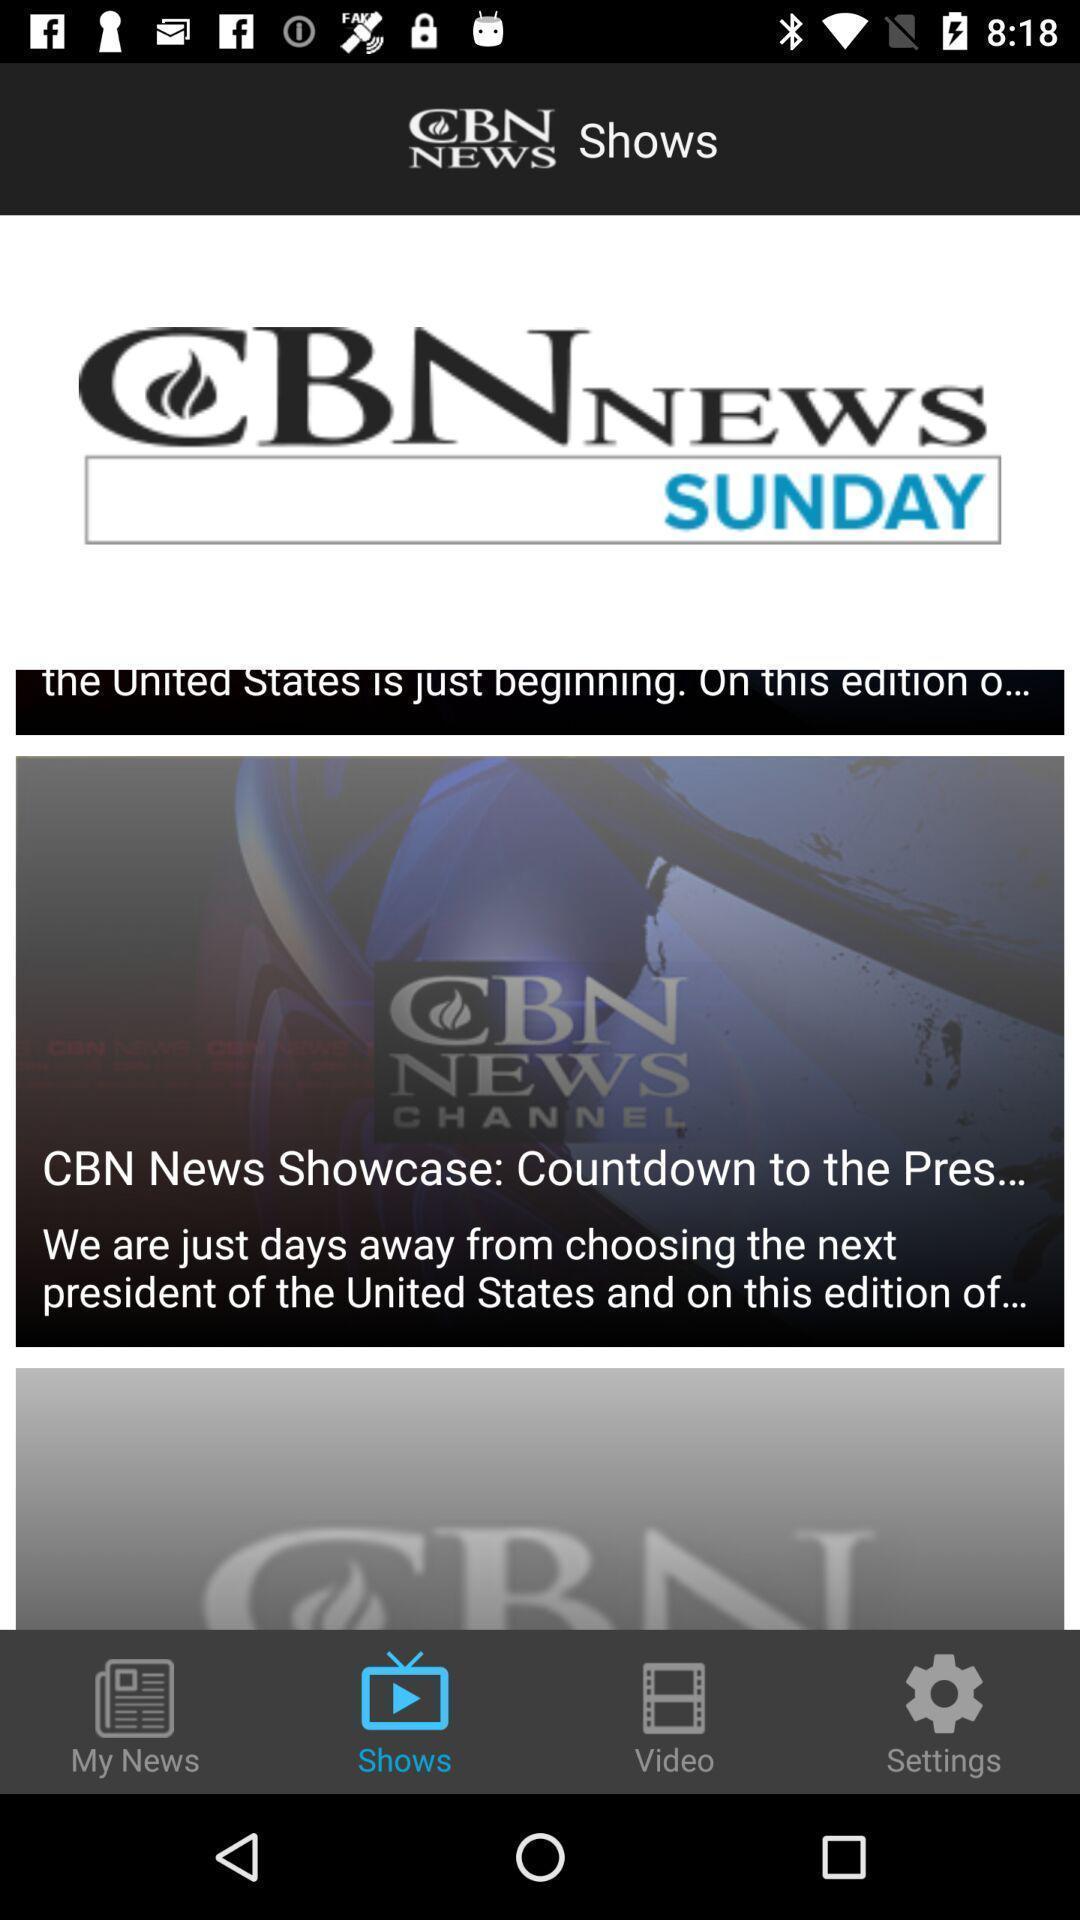Provide a description of this screenshot. Page displaying the news in a news app. 